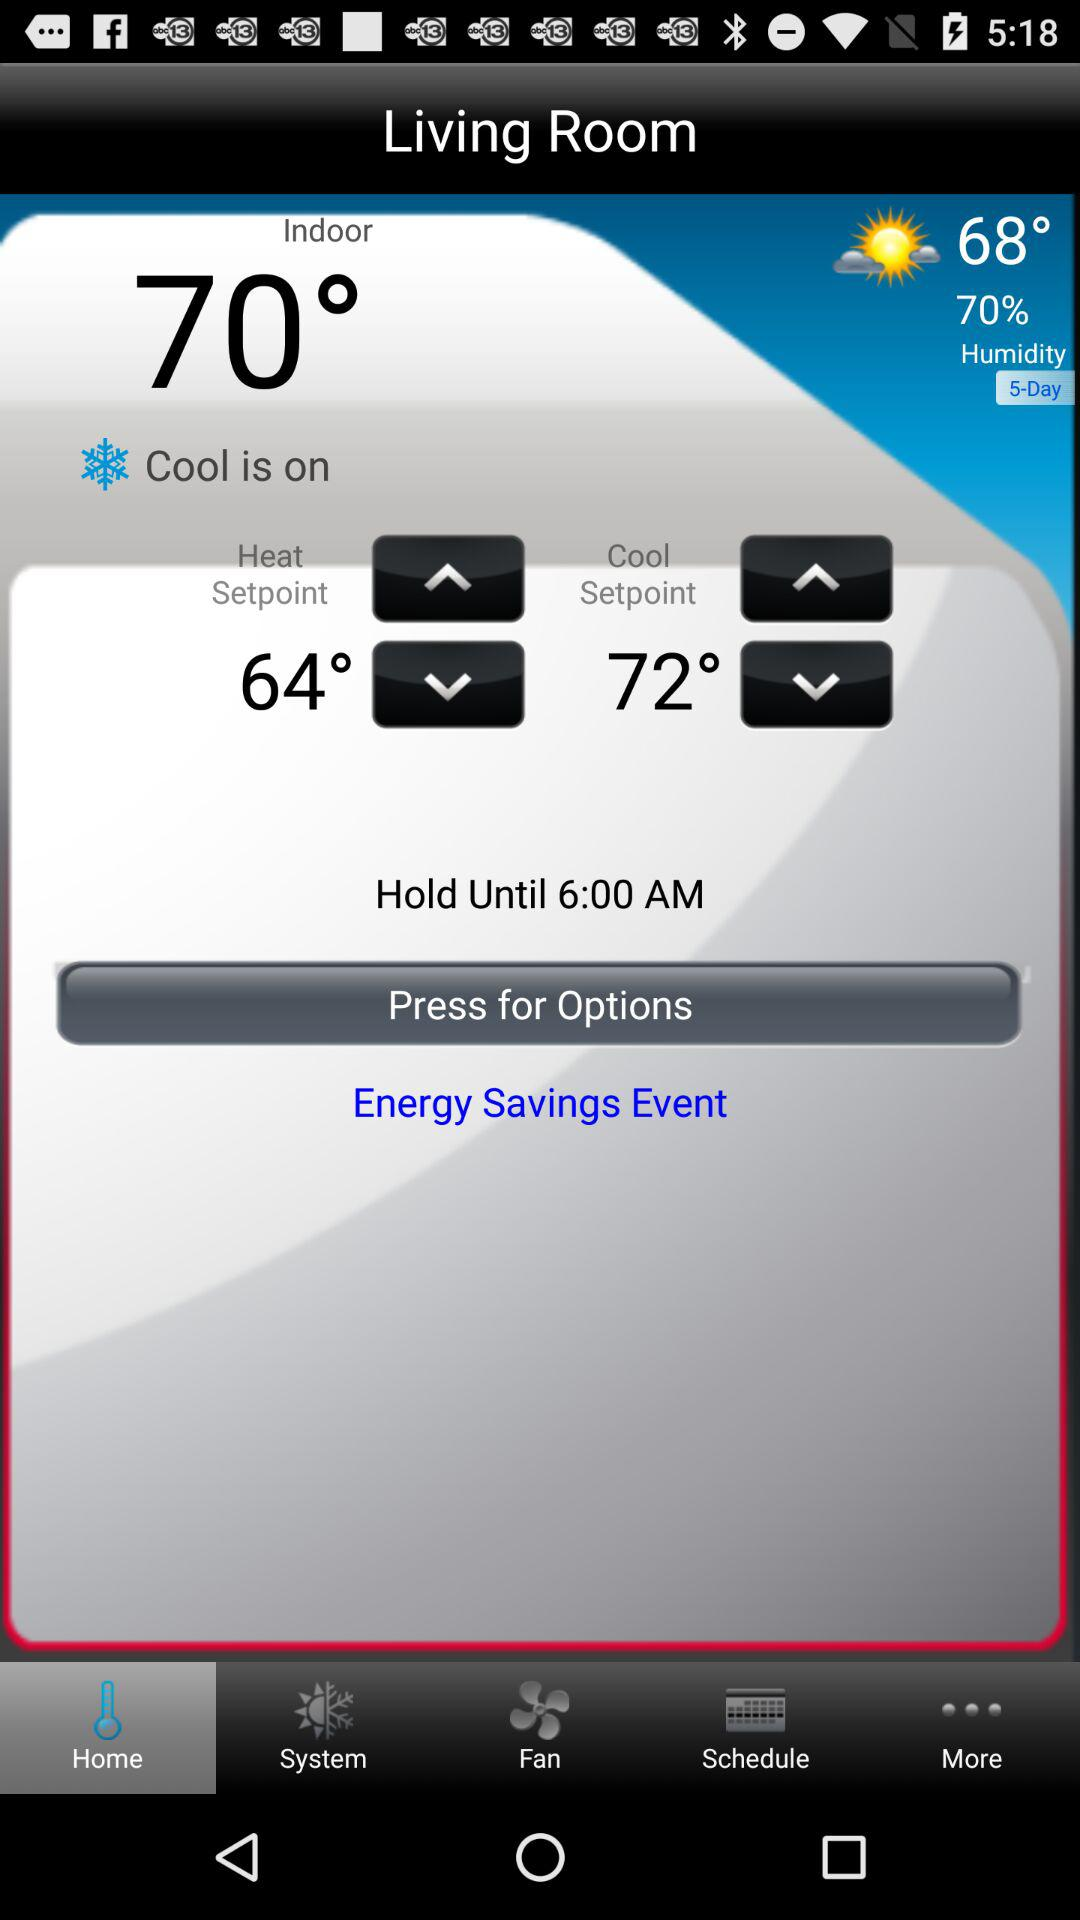Until what time should it be held? It should be held until 6 a.m. 